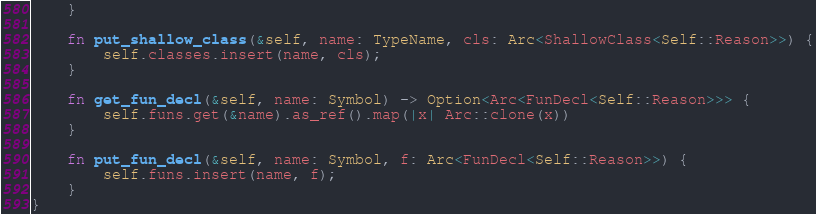Convert code to text. <code><loc_0><loc_0><loc_500><loc_500><_Rust_>    }

    fn put_shallow_class(&self, name: TypeName, cls: Arc<ShallowClass<Self::Reason>>) {
        self.classes.insert(name, cls);
    }

    fn get_fun_decl(&self, name: Symbol) -> Option<Arc<FunDecl<Self::Reason>>> {
        self.funs.get(&name).as_ref().map(|x| Arc::clone(x))
    }

    fn put_fun_decl(&self, name: Symbol, f: Arc<FunDecl<Self::Reason>>) {
        self.funs.insert(name, f);
    }
}
</code> 